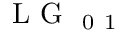Convert formula to latex. <formula><loc_0><loc_0><loc_500><loc_500>L G _ { 0 1 }</formula> 